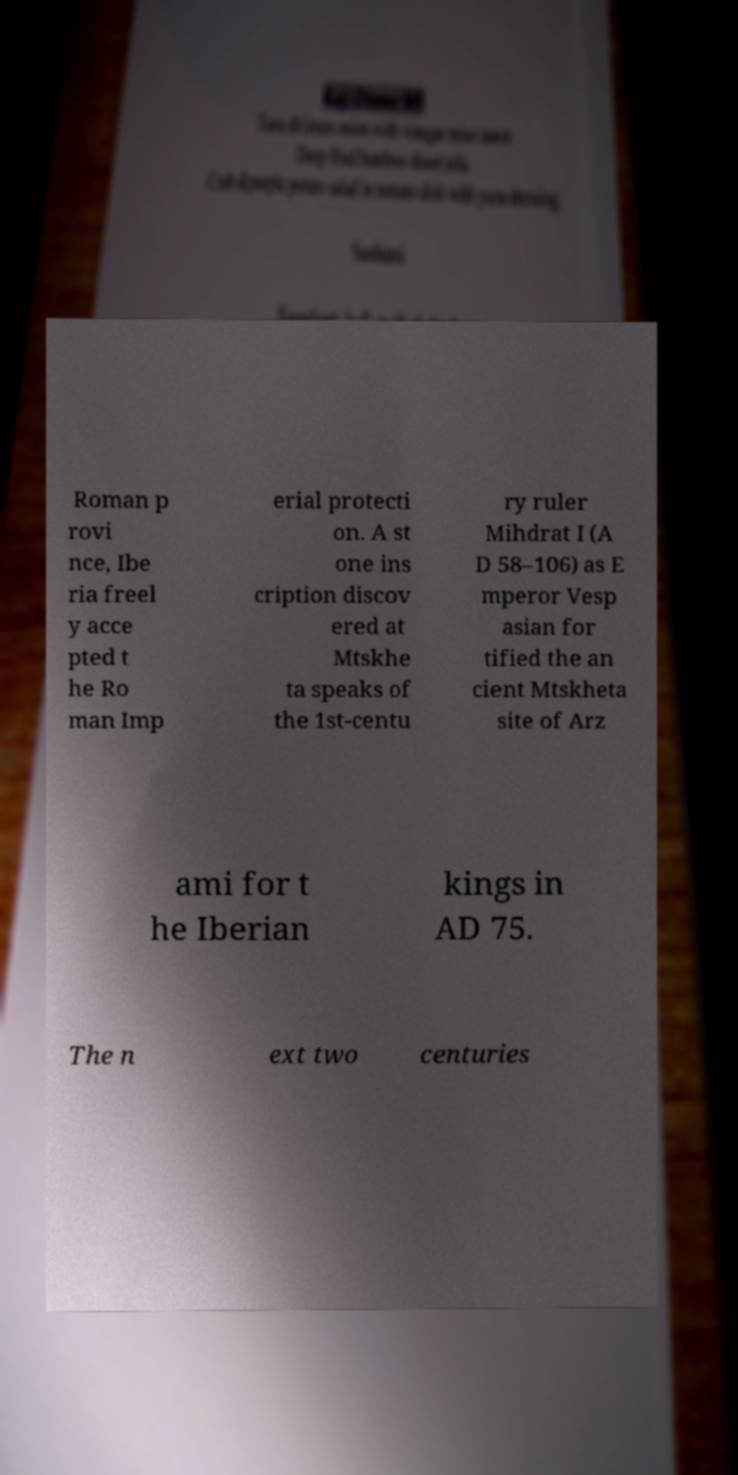I need the written content from this picture converted into text. Can you do that? Roman p rovi nce, Ibe ria freel y acce pted t he Ro man Imp erial protecti on. A st one ins cription discov ered at Mtskhe ta speaks of the 1st-centu ry ruler Mihdrat I (A D 58–106) as E mperor Vesp asian for tified the an cient Mtskheta site of Arz ami for t he Iberian kings in AD 75. The n ext two centuries 